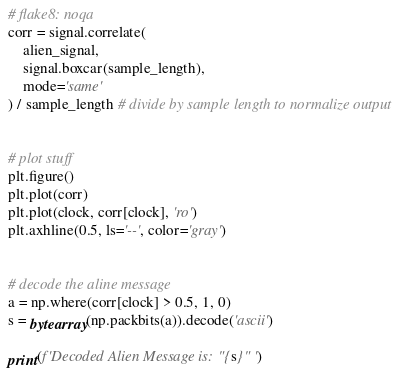Convert code to text. <code><loc_0><loc_0><loc_500><loc_500><_Python_># flake8: noqa
corr = signal.correlate(
    alien_signal,
    signal.boxcar(sample_length),
    mode='same'
) / sample_length # divide by sample length to normalize output


# plot stuff
plt.figure()
plt.plot(corr)
plt.plot(clock, corr[clock], 'ro')
plt.axhline(0.5, ls='--', color='gray')


# decode the aline message
a = np.where(corr[clock] > 0.5, 1, 0)
s = bytearray(np.packbits(a)).decode('ascii')

print(f'Decoded Alien Message is: "{s}" ')
</code> 